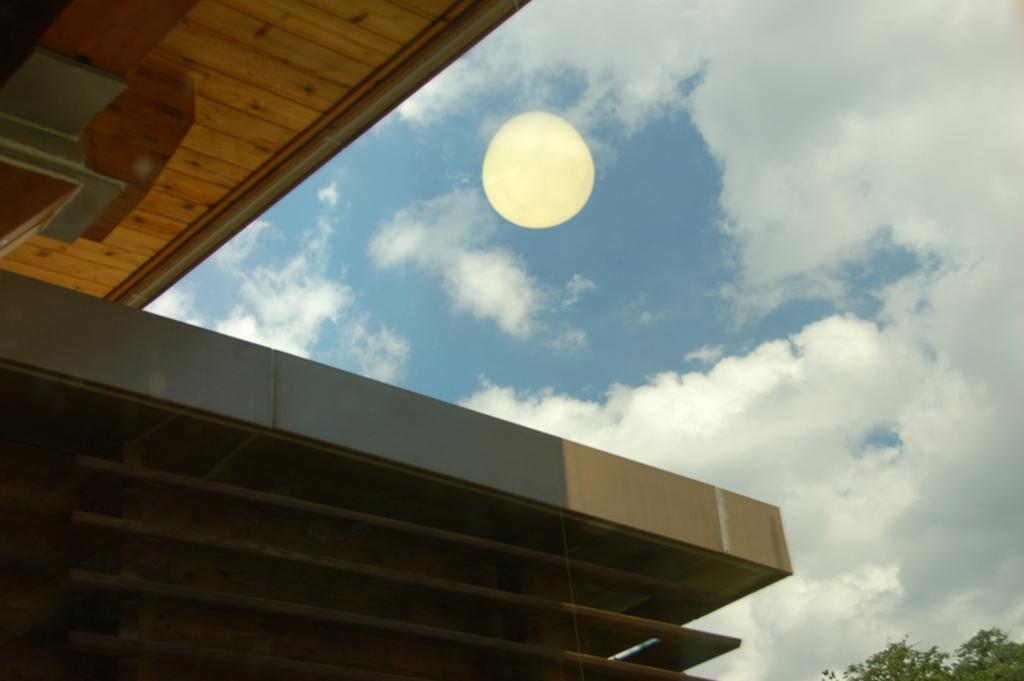Describe this image in one or two sentences. In this picture I can see the architecture of a building on the left side. In the middle it looks like a reflected image of a light on the glass. In the background I can see the sky, in the bottom right hand side there are trees. 